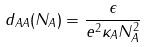<formula> <loc_0><loc_0><loc_500><loc_500>d _ { A A } ( N _ { A } ) = \frac { \epsilon } { e ^ { 2 } \kappa _ { A } N _ { A } ^ { 2 } }</formula> 